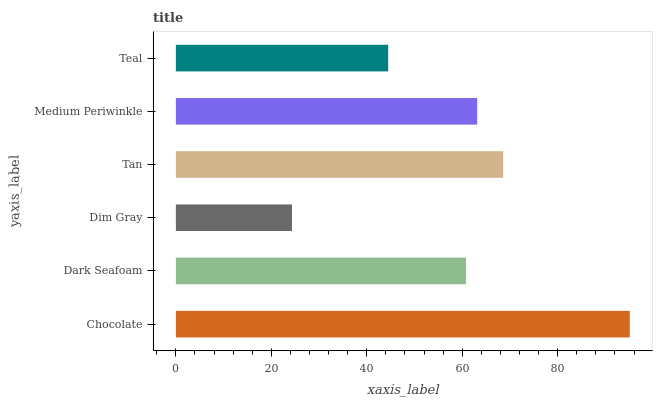Is Dim Gray the minimum?
Answer yes or no. Yes. Is Chocolate the maximum?
Answer yes or no. Yes. Is Dark Seafoam the minimum?
Answer yes or no. No. Is Dark Seafoam the maximum?
Answer yes or no. No. Is Chocolate greater than Dark Seafoam?
Answer yes or no. Yes. Is Dark Seafoam less than Chocolate?
Answer yes or no. Yes. Is Dark Seafoam greater than Chocolate?
Answer yes or no. No. Is Chocolate less than Dark Seafoam?
Answer yes or no. No. Is Medium Periwinkle the high median?
Answer yes or no. Yes. Is Dark Seafoam the low median?
Answer yes or no. Yes. Is Tan the high median?
Answer yes or no. No. Is Teal the low median?
Answer yes or no. No. 